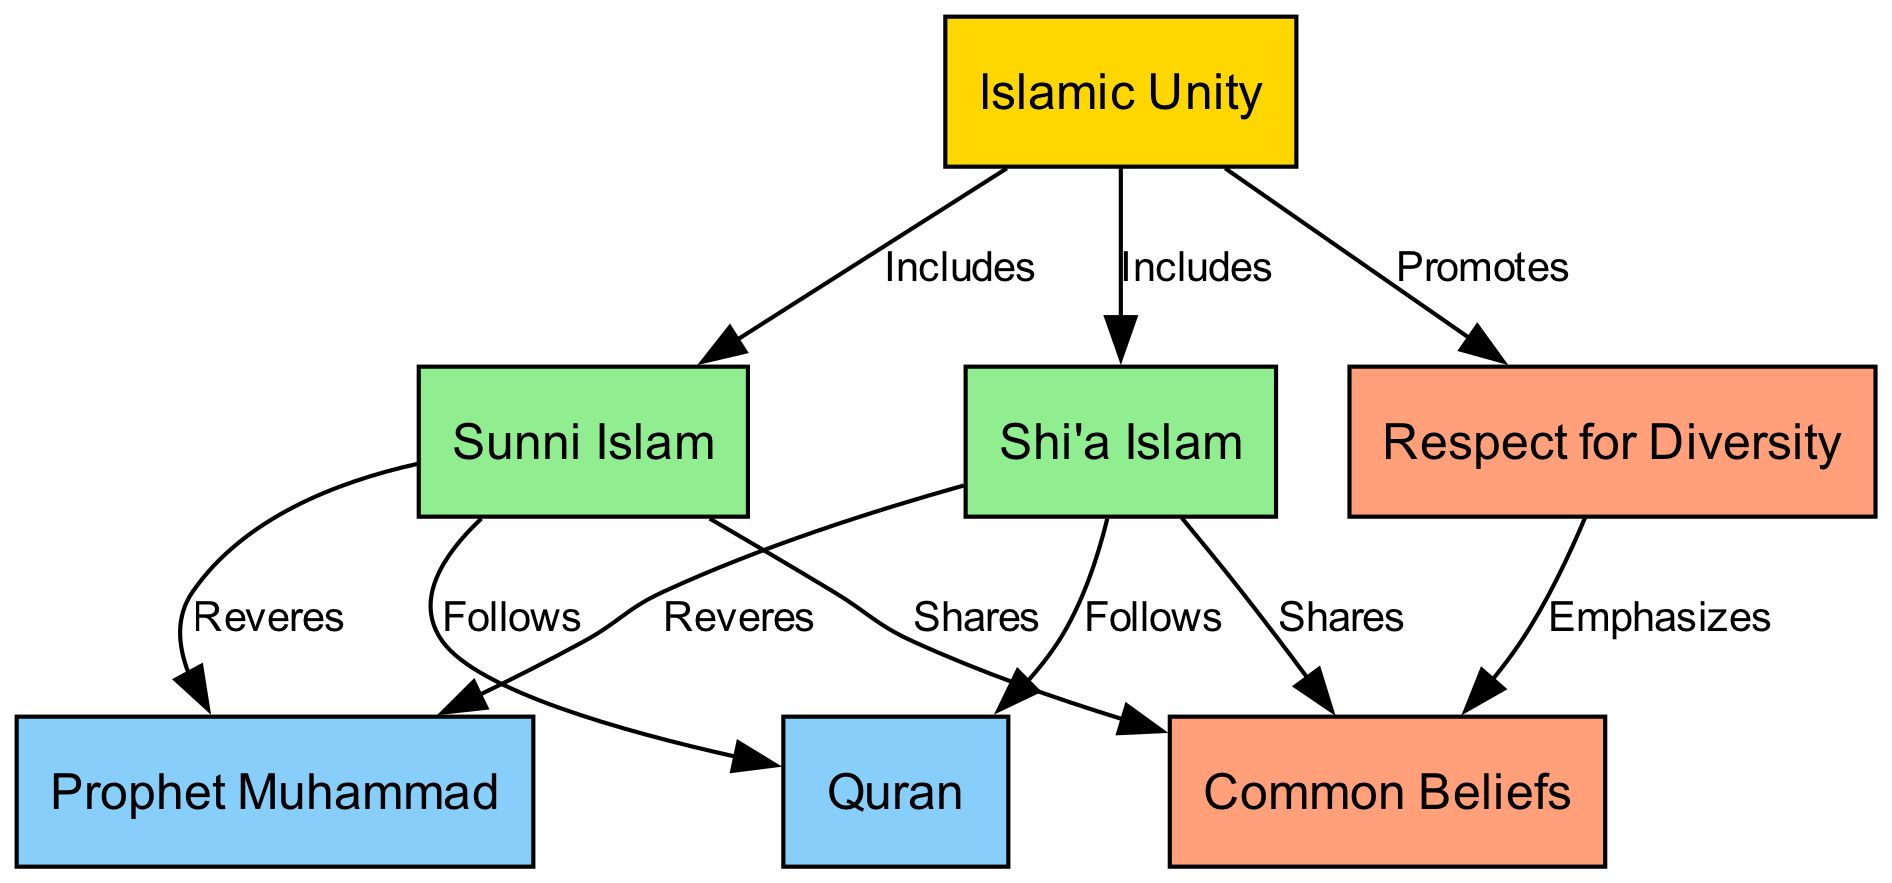What is at the top of the diagram? In the diagram, the first node listed is "Islamic Unity," which signifies the main concept being depicted. This node is positioned at the top of the diagram as it is the overarching theme.
Answer: Islamic Unity How many main branches are there under "Islamic Unity"? The diagram shows two main branches connected to "Islamic Unity," which are "Sunni Islam" and "Shi'a Islam." This indicates the primary divisions within the faith that are recognized.
Answer: 2 Which node is connected to both "Sunni Islam" and "Shi'a Islam"? The "Quran" node is linked to both "Sunni Islam" and "Shi'a Islam," indicating that all branches look to the Quran as a central text for guidance.
Answer: Quran What do "Sunni Islam" and "Shi'a Islam" have in common according to the diagram? Both "Sunni Islam" and "Shi'a Islam" share the node labeled "Common Beliefs," which emphasizes that despite their differences, they share fundamental Islamic beliefs.
Answer: Common Beliefs Which node emphasizes "Respect for Diversity"? The node titled "Respect for Diversity" directly connects to "Islamic Unity," indicating that it is a theme promoted by the concept of Islamic unity, highlighting its importance in the faith.
Answer: Respect for Diversity What is indicated by the edges connecting "Islamic Unity" to "Sunni Islam" and "Shi'a Islam"? The edges demonstrate that both branches are included under the overarching theme of "Islamic Unity," suggesting that despite doctrinal differences, both are part of a broader unity in Islam.
Answer: Includes Which node is revered by both branches of Islam? The node "Prophet Muhammad" is revered by both "Sunni Islam" and "Shi'a Islam," highlighting a shared veneration for the Prophet as a key figure in their faith tradition.
Answer: Prophet Muhammad What does the node "Respect for Diversity" emphasize in relation to common beliefs? The "Respect for Diversity" node emphasizes the importance of recognizing and upholding the different interpretations within Islam while still holding on to "Common Beliefs" among the various sects.
Answer: Emphasizes What relationship does "Respect for Diversity" have with "Islamic Unity"? "Respect for Diversity" promotes the idea of "Islamic Unity," suggesting that acknowledging differences is essential to achieving a unified understanding within the Islamic faith.
Answer: Promotes 